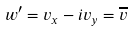Convert formula to latex. <formula><loc_0><loc_0><loc_500><loc_500>w ^ { \prime } = v _ { x } - i v _ { y } = \overline { v }</formula> 